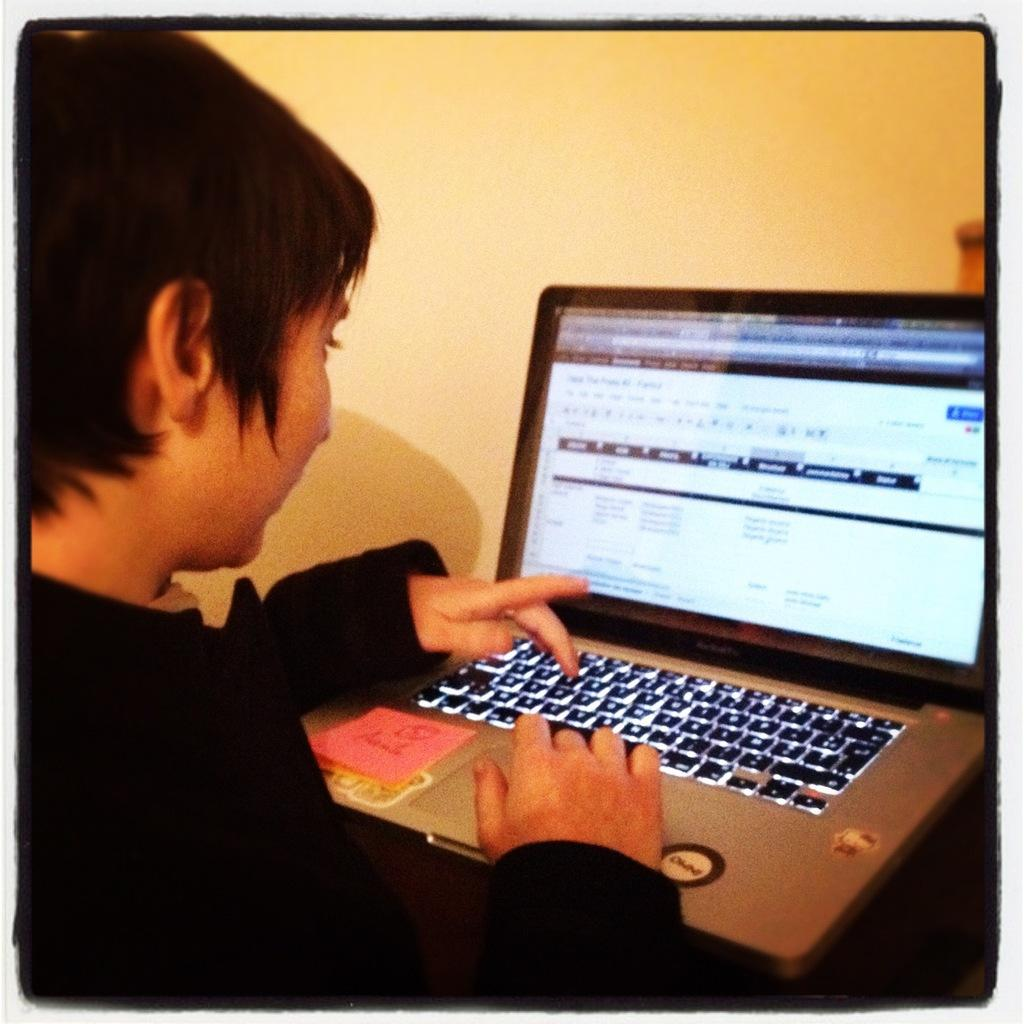What is the person in the image doing? The person is operating a laptop. What can be seen in the background of the image? There is a wall in the background of the image. What type of steel is being used to breathe in the image? There is no steel or breathing activity present in the image. 